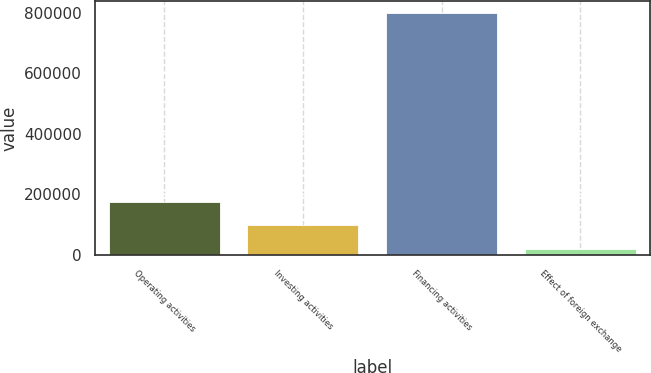Convert chart. <chart><loc_0><loc_0><loc_500><loc_500><bar_chart><fcel>Operating activities<fcel>Investing activities<fcel>Financing activities<fcel>Effect of foreign exchange<nl><fcel>176445<fcel>98531.3<fcel>799751<fcel>20618<nl></chart> 